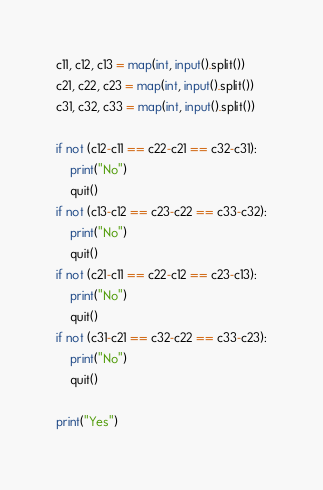<code> <loc_0><loc_0><loc_500><loc_500><_Python_>c11, c12, c13 = map(int, input().split())
c21, c22, c23 = map(int, input().split())
c31, c32, c33 = map(int, input().split())

if not (c12-c11 == c22-c21 == c32-c31):
    print("No")
    quit()
if not (c13-c12 == c23-c22 == c33-c32):
    print("No")
    quit()
if not (c21-c11 == c22-c12 == c23-c13):
    print("No")
    quit()
if not (c31-c21 == c32-c22 == c33-c23):
    print("No")
    quit()

print("Yes")</code> 